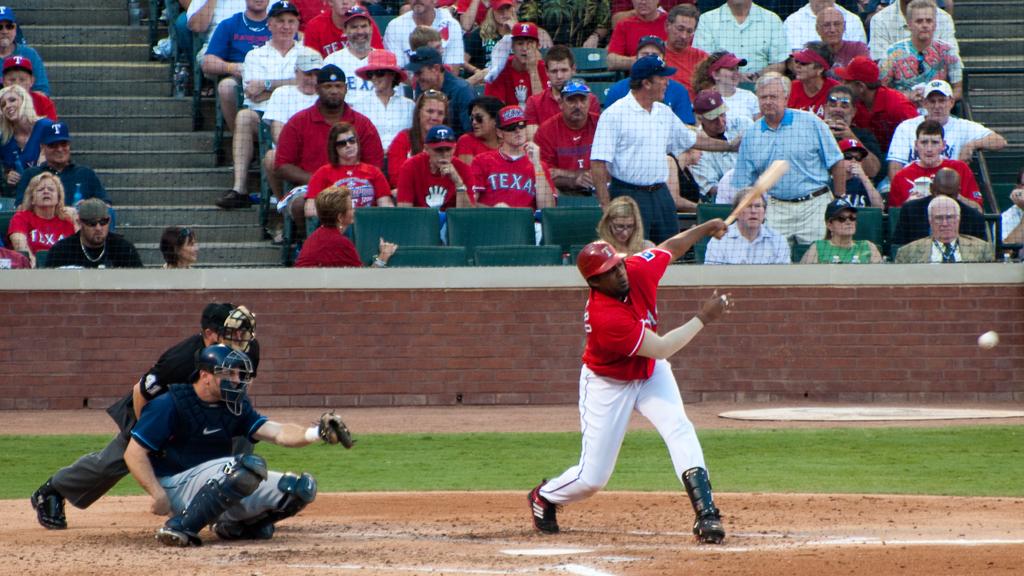In what state is this game probably being played?
Your answer should be compact. Texas. What team is on the mans shirt behind the batter?
Give a very brief answer. Texas. 